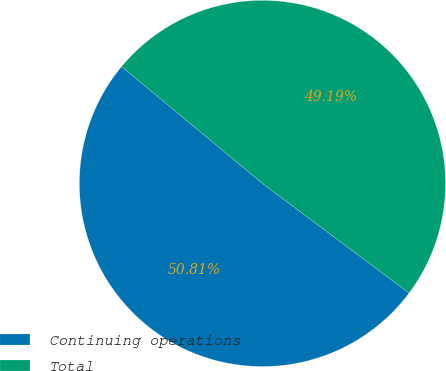<chart> <loc_0><loc_0><loc_500><loc_500><pie_chart><fcel>Continuing operations<fcel>Total<nl><fcel>50.81%<fcel>49.19%<nl></chart> 